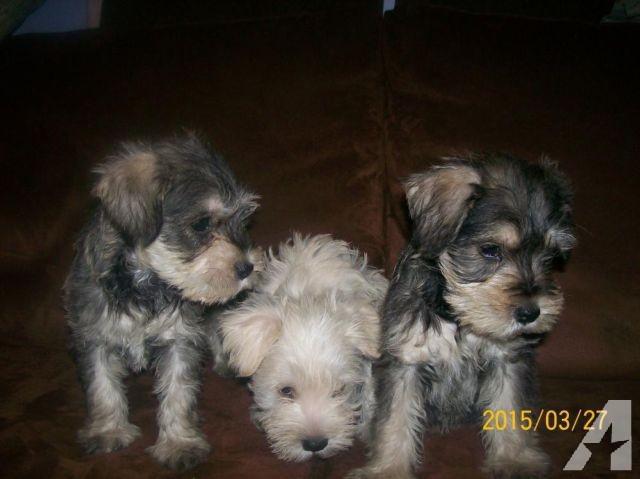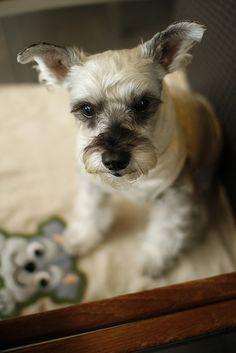The first image is the image on the left, the second image is the image on the right. Evaluate the accuracy of this statement regarding the images: "Each image contains one forward-facing schnauzer, and one image features a dog with a tag charm dangling under its chin.". Is it true? Answer yes or no. No. The first image is the image on the left, the second image is the image on the right. For the images displayed, is the sentence "The left image contains at least two dogs." factually correct? Answer yes or no. Yes. 